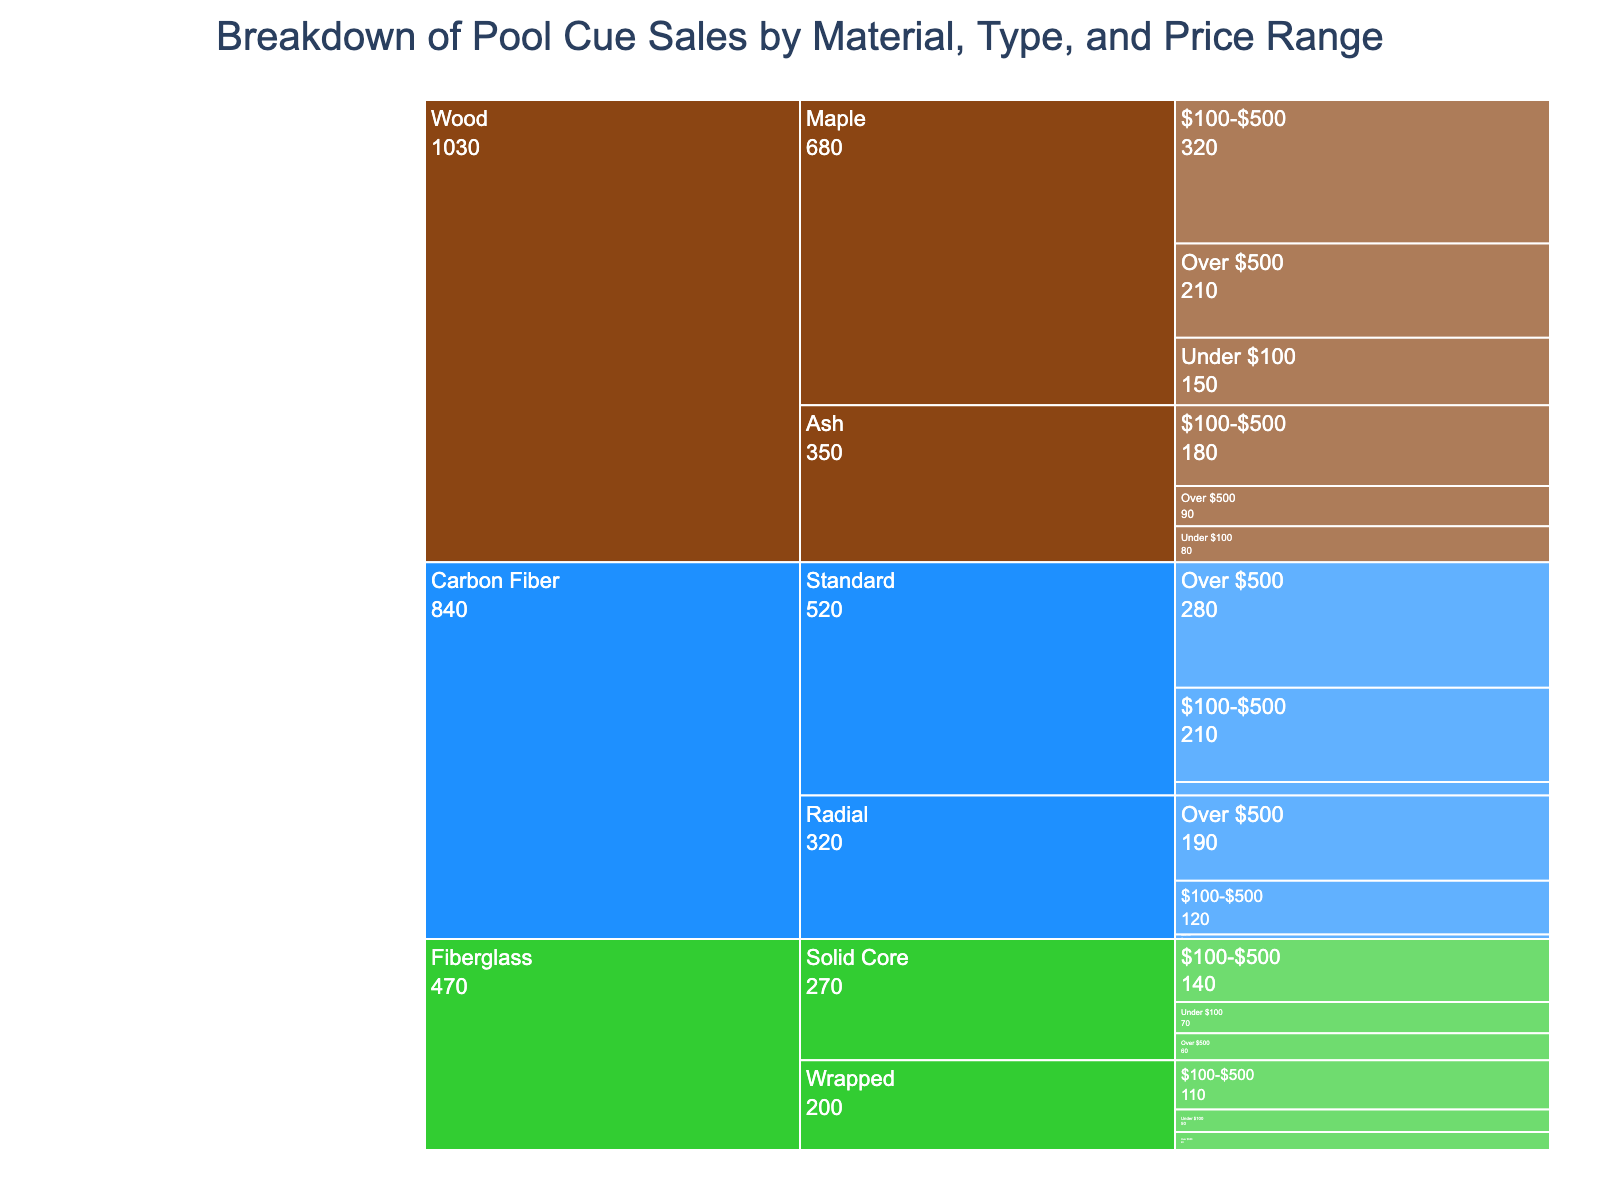What's the title of the chart? The title of the chart is displayed at the top and reads "Breakdown of Pool Cue Sales by Material, Type, and Price Range"
Answer: Breakdown of Pool Cue Sales by Material, Type, and Price Range How many material types are visualized in the chart? By looking at the colored segments in the chart, you can see that there are three material types: Wood, Carbon Fiber, and Fiberglass
Answer: 3 Which material type had the highest sales overall? Summing the sales for each material type: Wood sales are (150 + 320 + 210 + 80 + 180 + 90) = 1030, Carbon Fiber sales are (30 + 210 + 280 + 10 + 120 + 190) = 840, and Fiberglass sales are (70 + 140 + 60 + 50 + 110 + 40) = 470. Wood has the highest overall sales at 1030
Answer: Wood What are the sales for Carbon Fiber with a Standard type cue in the $100-$500 price range? By focusing on Carbon Fiber and its subcategory Standard, you see the sales in the $100-$500 price range are labeled as 210
Answer: 210 What is the total sales for cues in the Under $100 price range? Summing the Under $100 sales across all materials and types: (150 + 80 + 30 + 10 + 70 + 50) = 390
Answer: 390 Which type of Fiberglass cue had higher sales in the Over $500 price range, Solid Core or Wrapped? Comparing the two subcategories of Fiberglass, the sales for Over $500 are 60 for Solid Core and 40 for Wrapped. Solid Core had higher sales
Answer: Solid Core What is the average sales for Maple wood cues across all price ranges? The sales for Maple wood cues are (150 + 320 + 210). The sum is 680, and there are three price ranges, so the average is 680/3 = 226.67
Answer: 226.67 Between Ash and Maple wood cues in the $100-$500 price range, which one had higher sales? The sales for Maple wood cues in the $100-$500 price range are 320 and for Ash wood cues are 180, so Maple had higher sales
Answer: Maple What is the sales difference between Standard and Radial types of Carbon Fiber cues in the Over $500 price range? The sales for Standard Carbon Fiber cues in the Over $500 price range are 280, while for Radial, it is 190. The difference is 280 - 190 = 90
Answer: 90 For the entire chart, how many sales involve cues priced Over $500? Summing the sales for Over $500 price range across all materials and types: (210 + 90 + 280 + 190 + 60 + 40) = 870
Answer: 870 